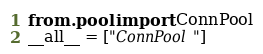<code> <loc_0><loc_0><loc_500><loc_500><_Python_>from .pool import ConnPool
__all__ = ["ConnPool"]</code> 